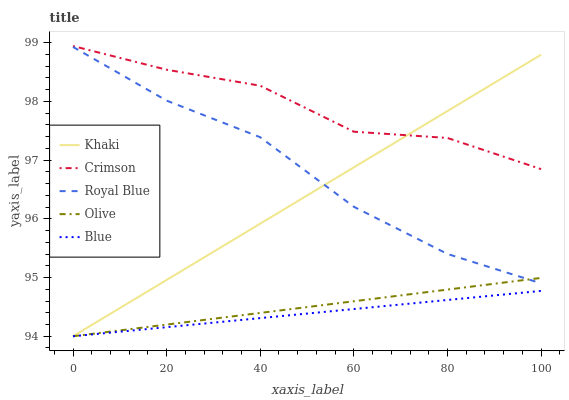Does Blue have the minimum area under the curve?
Answer yes or no. Yes. Does Crimson have the maximum area under the curve?
Answer yes or no. Yes. Does Royal Blue have the minimum area under the curve?
Answer yes or no. No. Does Royal Blue have the maximum area under the curve?
Answer yes or no. No. Is Blue the smoothest?
Answer yes or no. Yes. Is Crimson the roughest?
Answer yes or no. Yes. Is Royal Blue the smoothest?
Answer yes or no. No. Is Royal Blue the roughest?
Answer yes or no. No. Does Khaki have the lowest value?
Answer yes or no. Yes. Does Royal Blue have the lowest value?
Answer yes or no. No. Does Crimson have the highest value?
Answer yes or no. Yes. Does Royal Blue have the highest value?
Answer yes or no. No. Is Olive less than Crimson?
Answer yes or no. Yes. Is Crimson greater than Royal Blue?
Answer yes or no. Yes. Does Blue intersect Olive?
Answer yes or no. Yes. Is Blue less than Olive?
Answer yes or no. No. Is Blue greater than Olive?
Answer yes or no. No. Does Olive intersect Crimson?
Answer yes or no. No. 